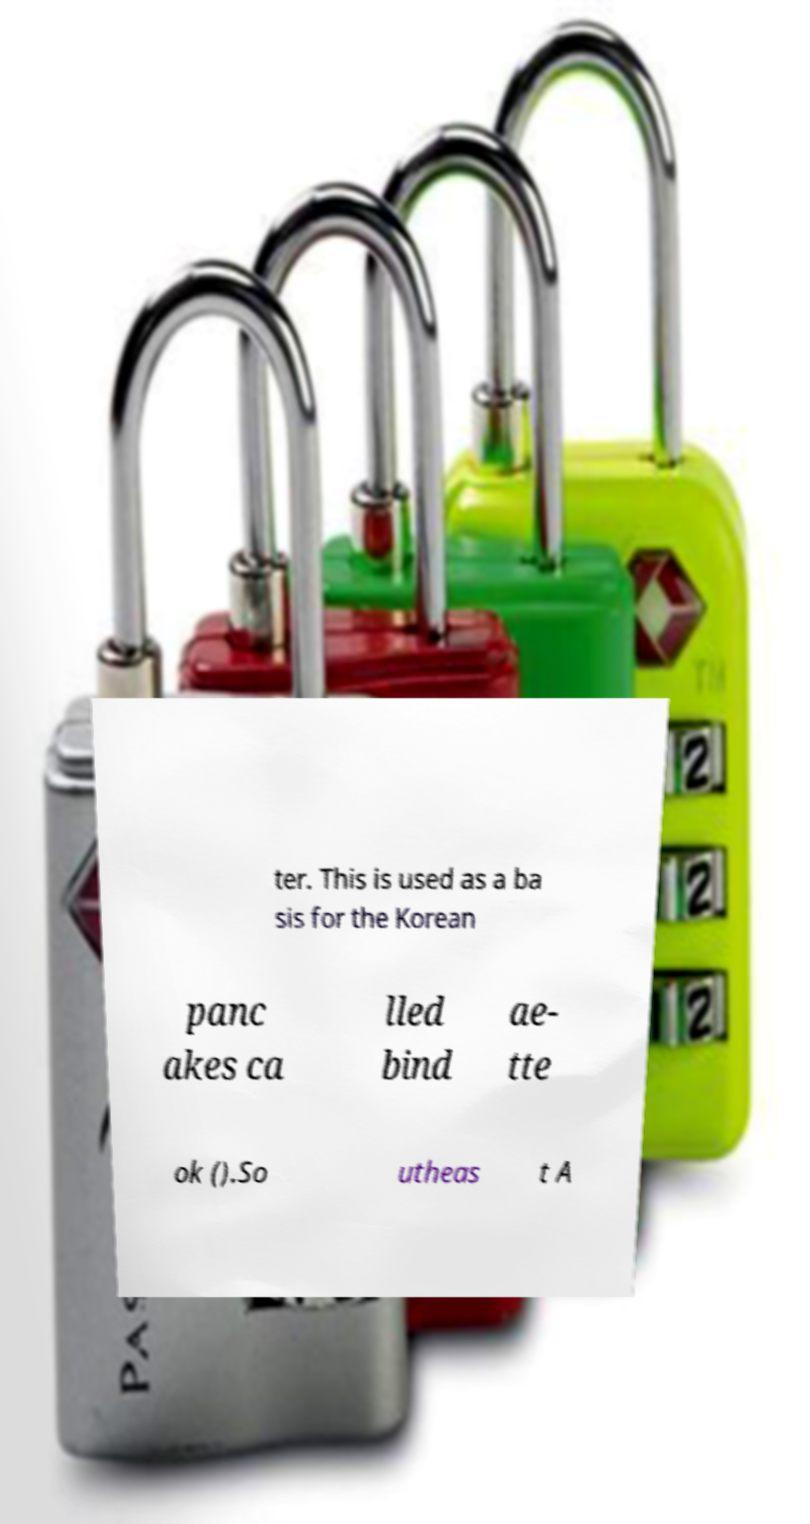Could you extract and type out the text from this image? ter. This is used as a ba sis for the Korean panc akes ca lled bind ae- tte ok ().So utheas t A 